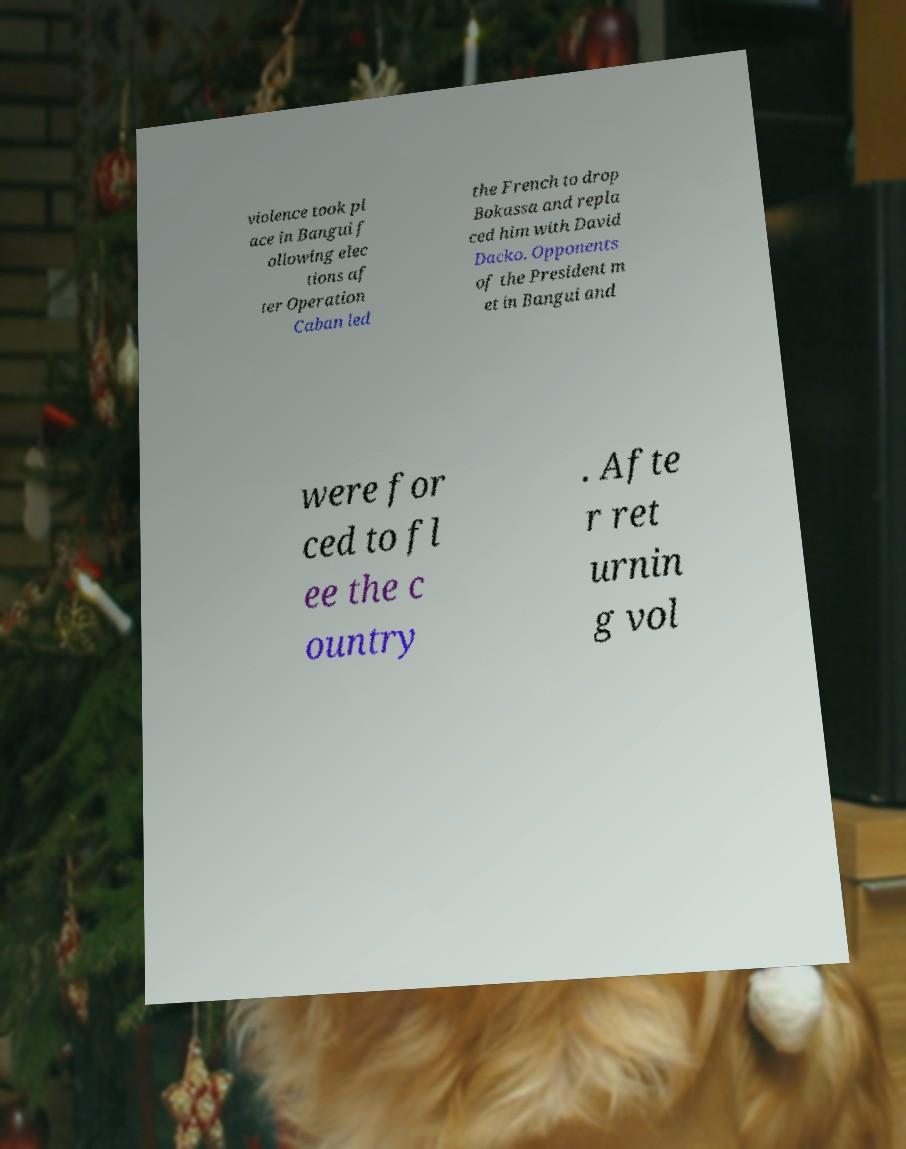Please identify and transcribe the text found in this image. violence took pl ace in Bangui f ollowing elec tions af ter Operation Caban led the French to drop Bokassa and repla ced him with David Dacko. Opponents of the President m et in Bangui and were for ced to fl ee the c ountry . Afte r ret urnin g vol 